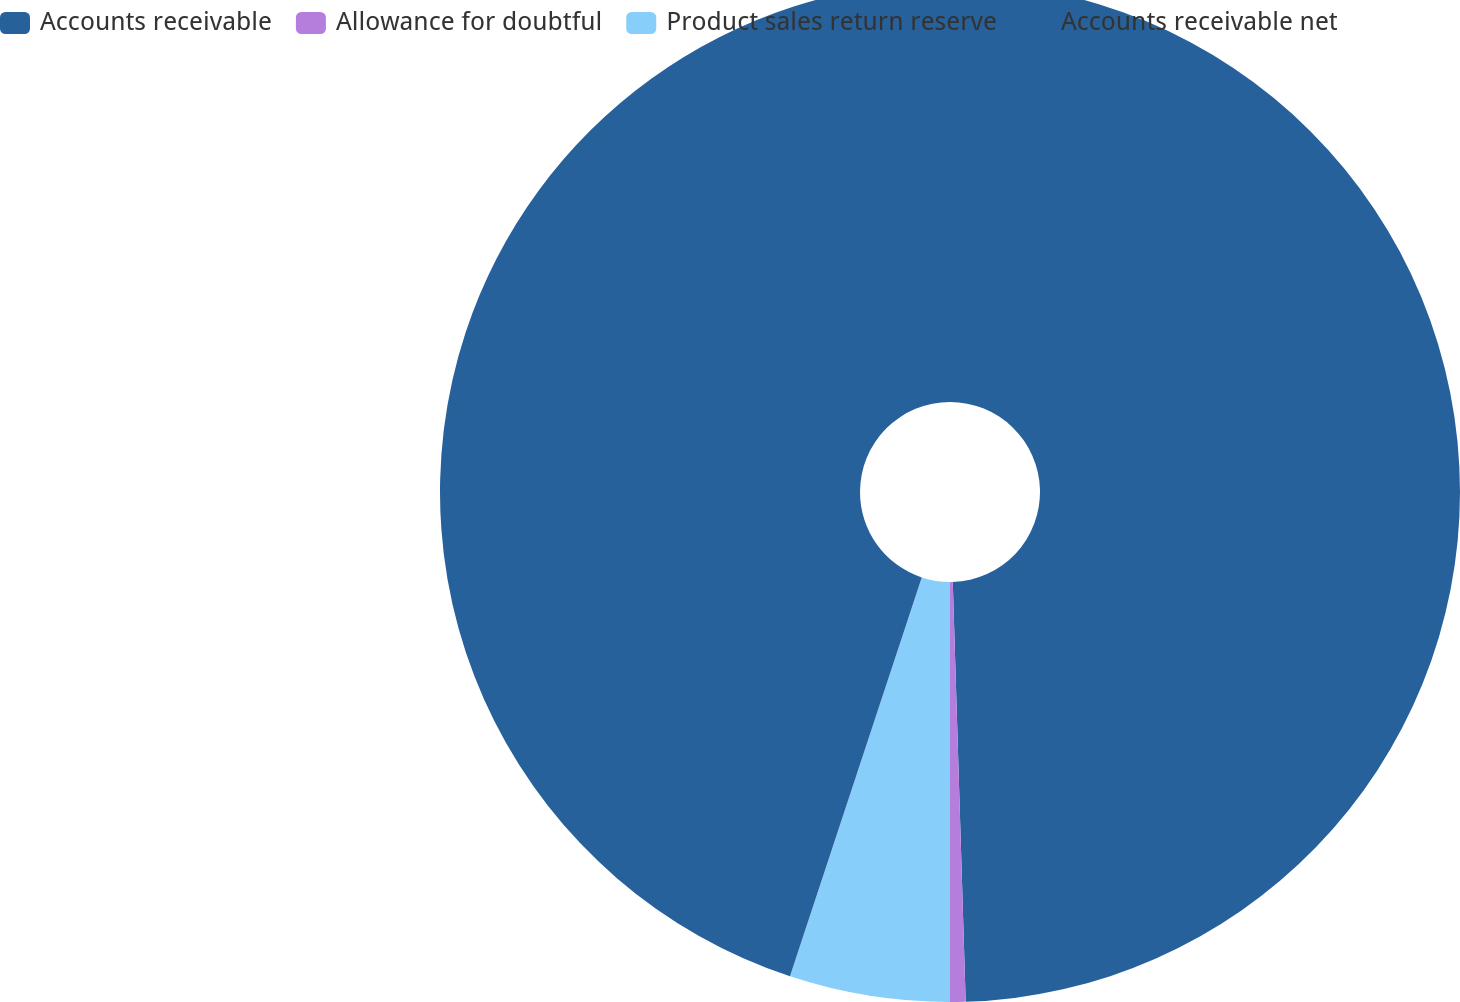Convert chart. <chart><loc_0><loc_0><loc_500><loc_500><pie_chart><fcel>Accounts receivable<fcel>Allowance for doubtful<fcel>Product sales return reserve<fcel>Accounts receivable net<nl><fcel>49.51%<fcel>0.49%<fcel>5.08%<fcel>44.92%<nl></chart> 